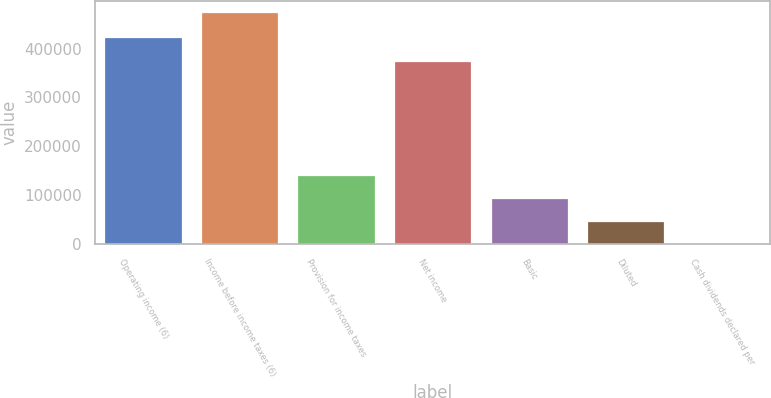<chart> <loc_0><loc_0><loc_500><loc_500><bar_chart><fcel>Operating income (6)<fcel>Income before income taxes (6)<fcel>Provision for income taxes<fcel>Net income<fcel>Basic<fcel>Diluted<fcel>Cash dividends declared per<nl><fcel>424194<fcel>474094<fcel>142229<fcel>374047<fcel>94819.2<fcel>47409.8<fcel>0.48<nl></chart> 